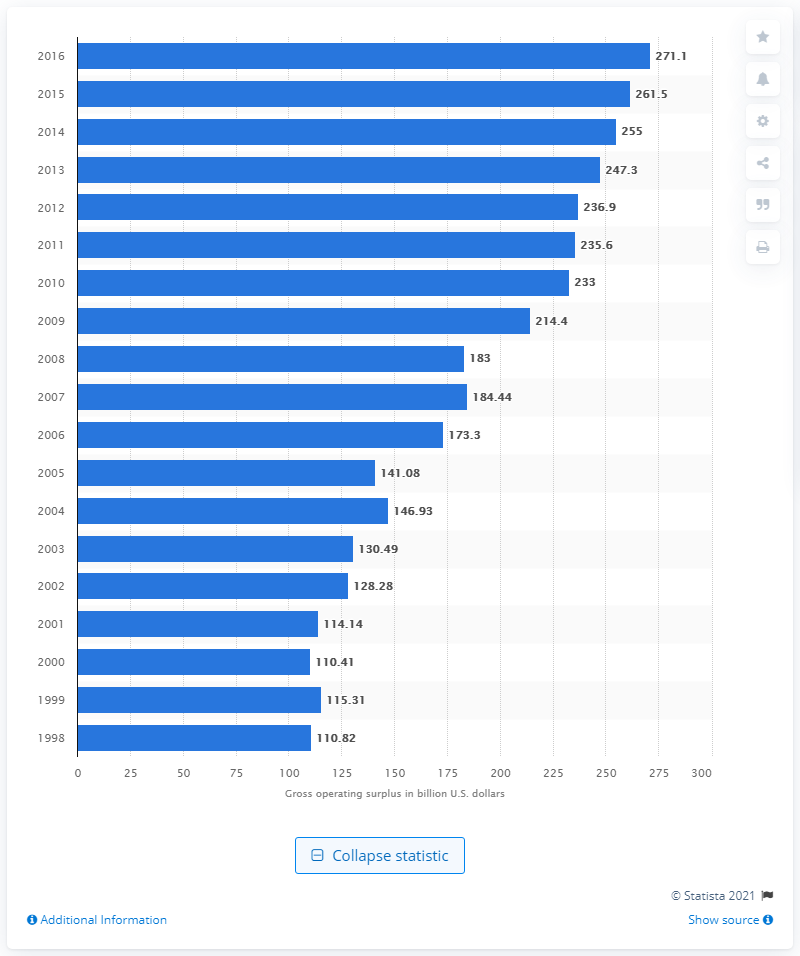Draw attention to some important aspects in this diagram. In 2016, the gross operating surplus of chemical products manufacturing in the United States was 271.1 million U.S. dollars. 